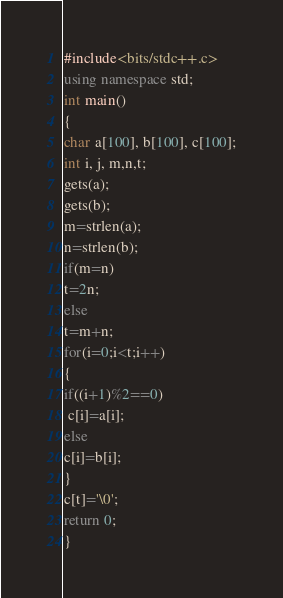Convert code to text. <code><loc_0><loc_0><loc_500><loc_500><_C++_>#include<bits/stdc++.c>
using namespace std;
int main()
{
char a[100], b[100], c[100];
int i, j, m,n,t;
gets(a);
gets(b);
m=strlen(a);
n=strlen(b);
if(m=n)
t=2n;
else
t=m+n;
for(i=0;i<t;i++)
{ 
if((i+1)%2==0)
 c[i]=a[i];
else
c[i]=b[i];
}
c[t]='\0';
return 0;
}</code> 